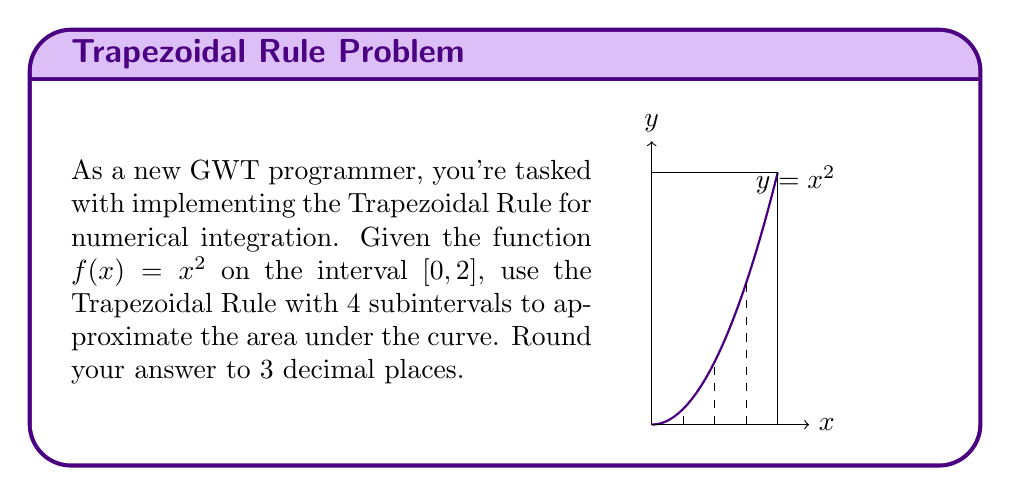Help me with this question. Let's approach this step-by-step:

1) The Trapezoidal Rule formula for n subintervals is:

   $$\int_a^b f(x)dx \approx \frac{b-a}{2n}\left[f(a) + 2\sum_{i=1}^{n-1}f(x_i) + f(b)\right]$$

2) Here, $a=0$, $b=2$, and $n=4$. The width of each subinterval is $h = \frac{b-a}{n} = \frac{2-0}{4} = 0.5$.

3) We need to calculate $f(x)$ at $x = 0, 0.5, 1, 1.5, 2$:
   
   $f(0) = 0^2 = 0$
   $f(0.5) = 0.5^2 = 0.25$
   $f(1) = 1^2 = 1$
   $f(1.5) = 1.5^2 = 2.25$
   $f(2) = 2^2 = 4$

4) Applying the formula:

   $$\begin{align}
   \int_0^2 x^2dx &\approx \frac{2-0}{2(4)}[f(0) + 2(f(0.5) + f(1) + f(1.5)) + f(2)] \\
   &= \frac{1}{4}[0 + 2(0.25 + 1 + 2.25) + 4] \\
   &= \frac{1}{4}[0 + 2(3.5) + 4] \\
   &= \frac{1}{4}[7 + 4] \\
   &= \frac{11}{4} \\
   &= 2.75
   \end{align}$$

5) Rounding to 3 decimal places: 2.750
Answer: 2.750 